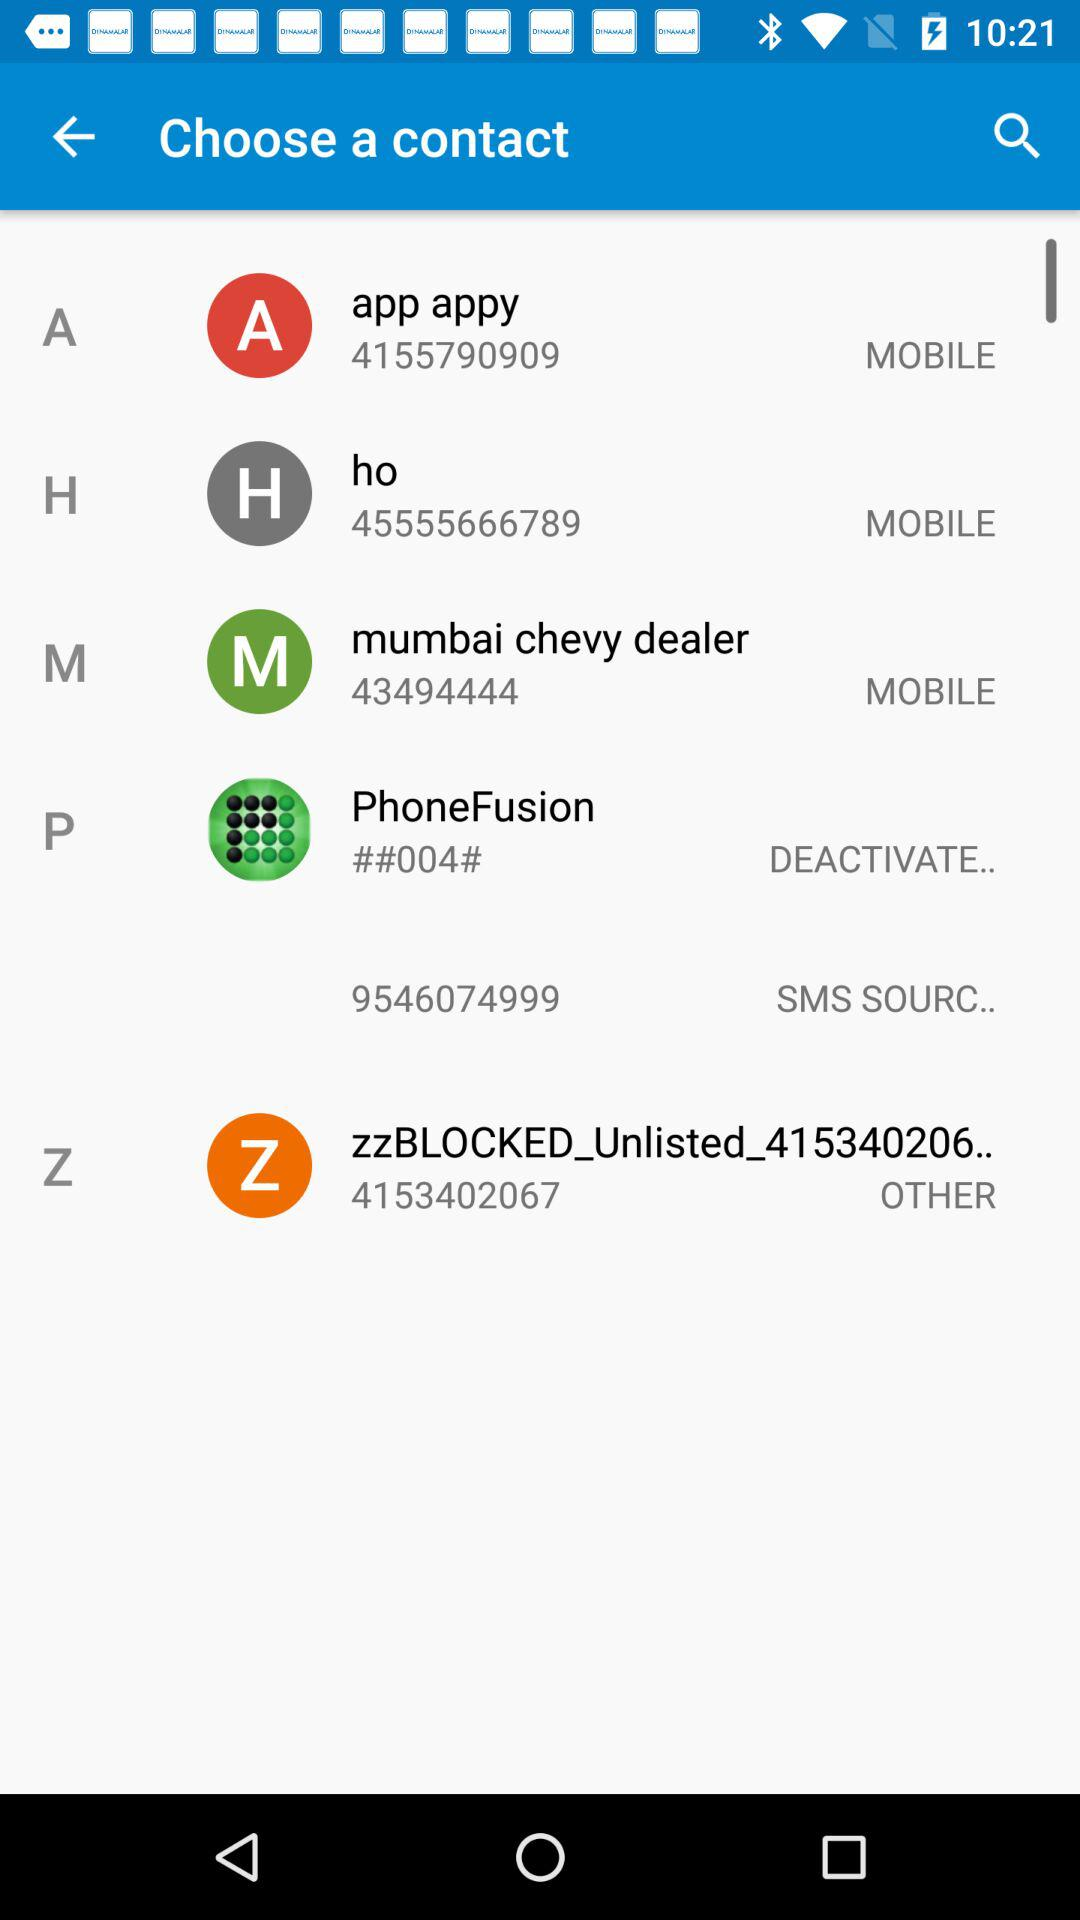What number is shown for "mumbai chevy dealer"? The shown number for "mumbai chevy dealer" is 43494444. 